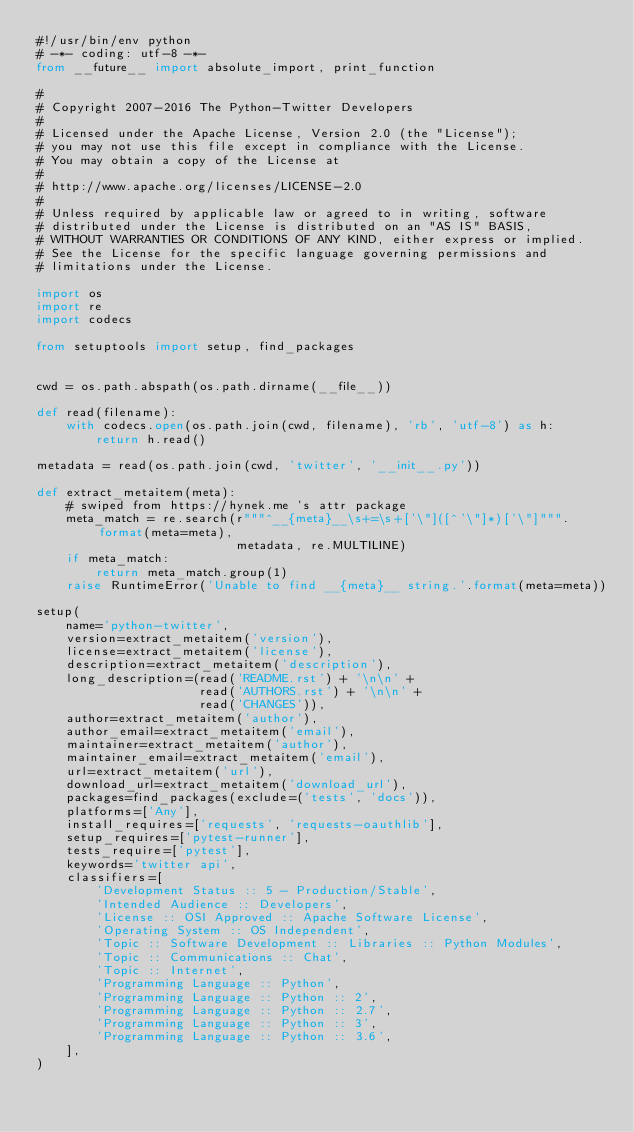Convert code to text. <code><loc_0><loc_0><loc_500><loc_500><_Python_>#!/usr/bin/env python
# -*- coding: utf-8 -*-
from __future__ import absolute_import, print_function

#
# Copyright 2007-2016 The Python-Twitter Developers
#
# Licensed under the Apache License, Version 2.0 (the "License");
# you may not use this file except in compliance with the License.
# You may obtain a copy of the License at
#
# http://www.apache.org/licenses/LICENSE-2.0
#
# Unless required by applicable law or agreed to in writing, software
# distributed under the License is distributed on an "AS IS" BASIS,
# WITHOUT WARRANTIES OR CONDITIONS OF ANY KIND, either express or implied.
# See the License for the specific language governing permissions and
# limitations under the License.

import os
import re
import codecs

from setuptools import setup, find_packages


cwd = os.path.abspath(os.path.dirname(__file__))

def read(filename):
    with codecs.open(os.path.join(cwd, filename), 'rb', 'utf-8') as h:
        return h.read()

metadata = read(os.path.join(cwd, 'twitter', '__init__.py'))

def extract_metaitem(meta):
    # swiped from https://hynek.me 's attr package
    meta_match = re.search(r"""^__{meta}__\s+=\s+['\"]([^'\"]*)['\"]""".format(meta=meta),
                           metadata, re.MULTILINE)
    if meta_match:
        return meta_match.group(1)
    raise RuntimeError('Unable to find __{meta}__ string.'.format(meta=meta))

setup(
    name='python-twitter',
    version=extract_metaitem('version'),
    license=extract_metaitem('license'),
    description=extract_metaitem('description'),
    long_description=(read('README.rst') + '\n\n' +
                      read('AUTHORS.rst') + '\n\n' +
                      read('CHANGES')),
    author=extract_metaitem('author'),
    author_email=extract_metaitem('email'),
    maintainer=extract_metaitem('author'),
    maintainer_email=extract_metaitem('email'),
    url=extract_metaitem('url'),
    download_url=extract_metaitem('download_url'),
    packages=find_packages(exclude=('tests', 'docs')),
    platforms=['Any'],
    install_requires=['requests', 'requests-oauthlib'],
    setup_requires=['pytest-runner'],
    tests_require=['pytest'],
    keywords='twitter api',
    classifiers=[
        'Development Status :: 5 - Production/Stable',
        'Intended Audience :: Developers',
        'License :: OSI Approved :: Apache Software License',
        'Operating System :: OS Independent',
        'Topic :: Software Development :: Libraries :: Python Modules',
        'Topic :: Communications :: Chat',
        'Topic :: Internet',
        'Programming Language :: Python',
        'Programming Language :: Python :: 2',
        'Programming Language :: Python :: 2.7',
        'Programming Language :: Python :: 3',
        'Programming Language :: Python :: 3.6',
    ],
)
</code> 